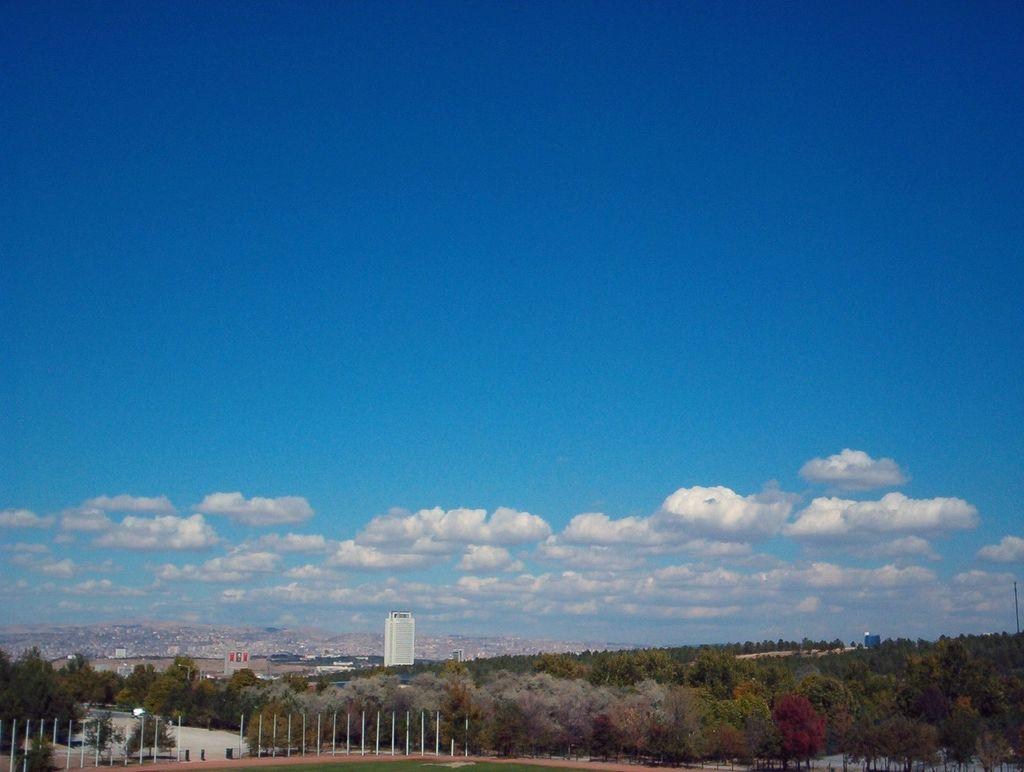What is located in the center of the image? There are poles in the center of the image. What type of natural elements can be seen in the image? There are trees in the image. What type of man-made structures are visible in the background? There are buildings in the background of the image. How would you describe the weather in the image? The sky is cloudy in the image, suggesting a potentially overcast or rainy day. What type of hair can be seen on the owl in the image? There is no owl present in the image, so there is no hair to observe. 